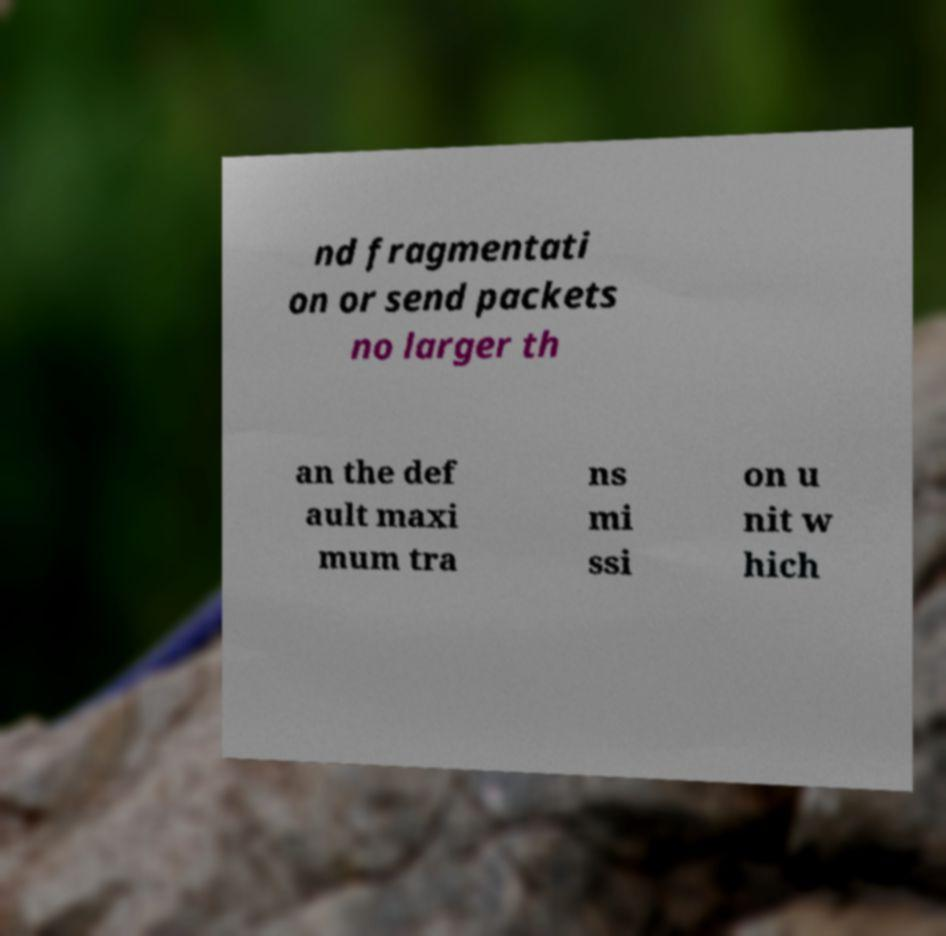Can you read and provide the text displayed in the image?This photo seems to have some interesting text. Can you extract and type it out for me? nd fragmentati on or send packets no larger th an the def ault maxi mum tra ns mi ssi on u nit w hich 